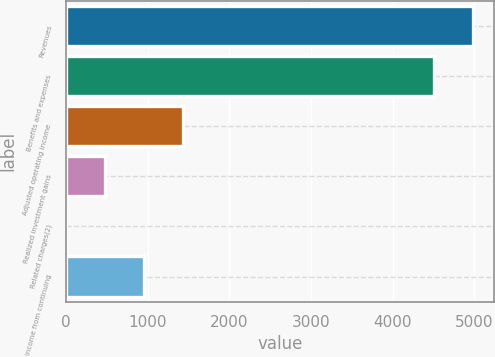<chart> <loc_0><loc_0><loc_500><loc_500><bar_chart><fcel>Revenues<fcel>Benefits and expenses<fcel>Adjusted operating income<fcel>Realized investment gains<fcel>Related charges(2)<fcel>Income from continuing<nl><fcel>4992<fcel>4513<fcel>1439<fcel>481<fcel>2<fcel>960<nl></chart> 